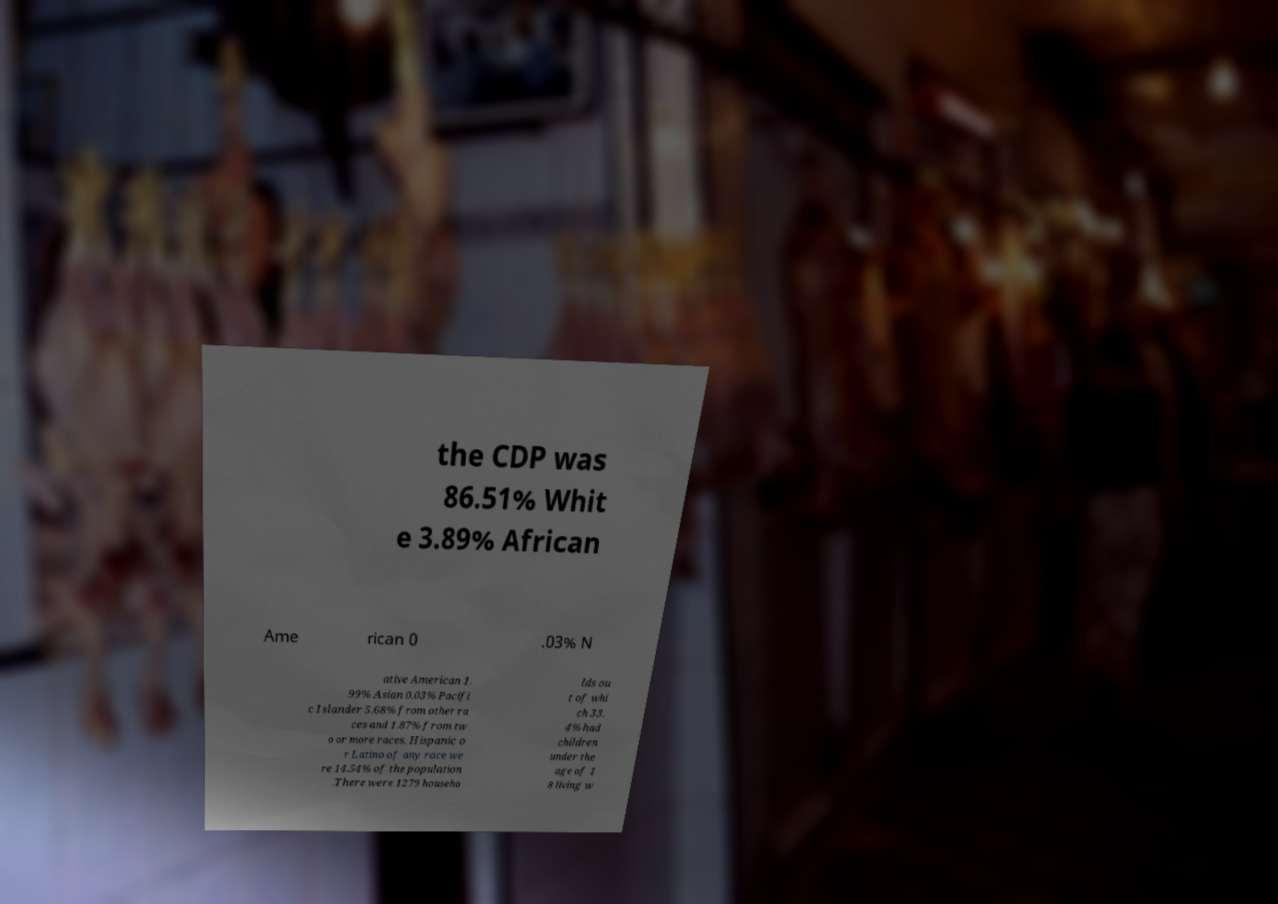Can you accurately transcribe the text from the provided image for me? the CDP was 86.51% Whit e 3.89% African Ame rican 0 .03% N ative American 1. 99% Asian 0.03% Pacifi c Islander 5.68% from other ra ces and 1.87% from tw o or more races. Hispanic o r Latino of any race we re 14.54% of the population .There were 1279 househo lds ou t of whi ch 33. 4% had children under the age of 1 8 living w 